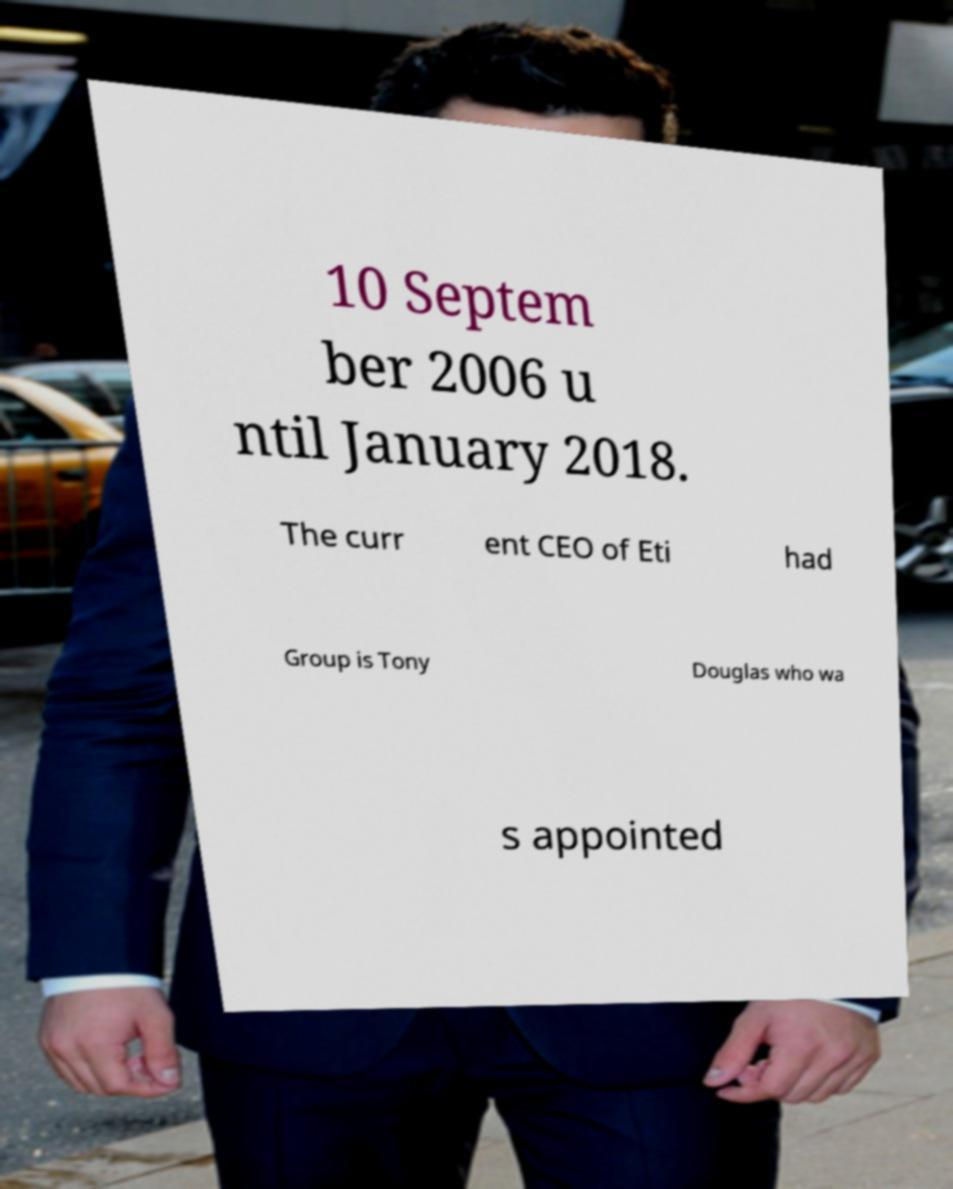There's text embedded in this image that I need extracted. Can you transcribe it verbatim? 10 Septem ber 2006 u ntil January 2018. The curr ent CEO of Eti had Group is Tony Douglas who wa s appointed 